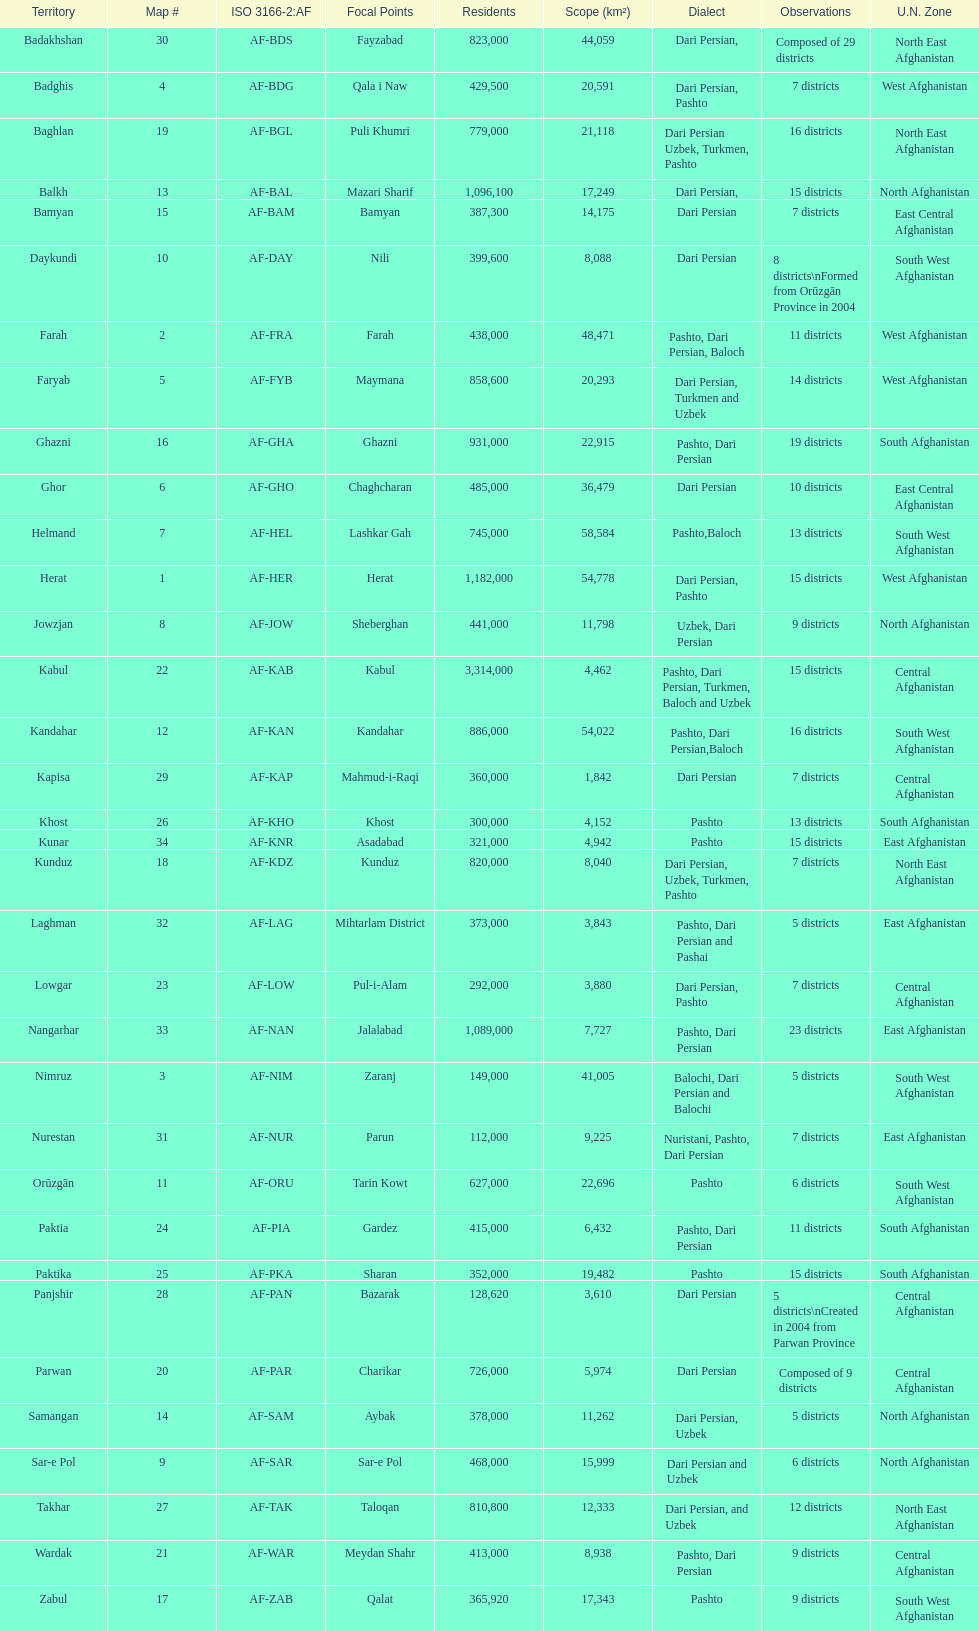Herat has a population of 1,182,000, can you list their languages Dari Persian, Pashto. 